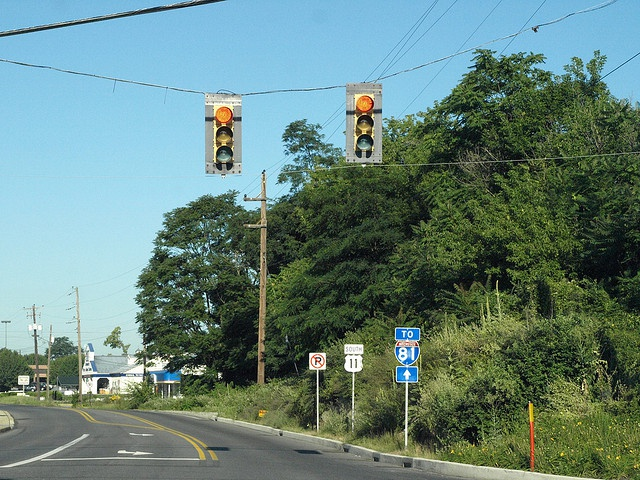Describe the objects in this image and their specific colors. I can see traffic light in lightblue, black, khaki, olive, and orange tones and traffic light in lightblue, black, khaki, olive, and orange tones in this image. 